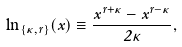<formula> <loc_0><loc_0><loc_500><loc_500>\ln _ { \{ \kappa , r \} } ( x ) \equiv \frac { x ^ { r + \kappa } - x ^ { r - \kappa } } { 2 \kappa } ,</formula> 